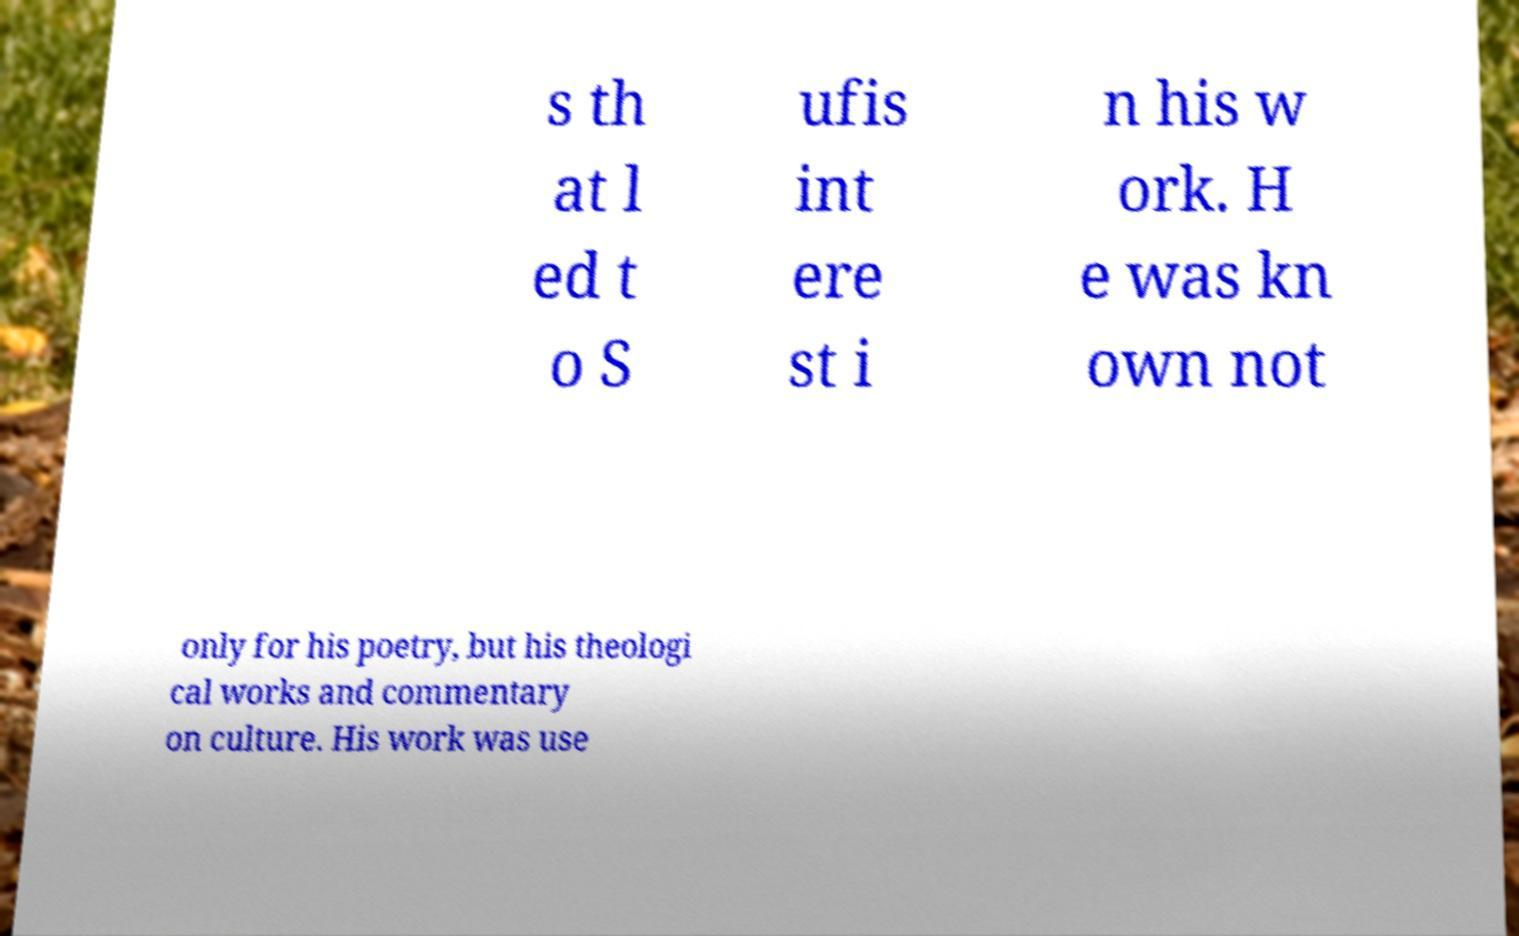Could you extract and type out the text from this image? s th at l ed t o S ufis int ere st i n his w ork. H e was kn own not only for his poetry, but his theologi cal works and commentary on culture. His work was use 